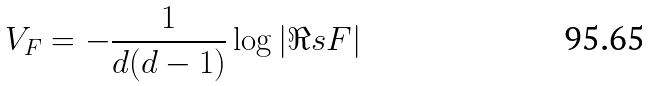<formula> <loc_0><loc_0><loc_500><loc_500>V _ { F } = - \frac { 1 } { d ( d - 1 ) } \log | \Re s F |</formula> 